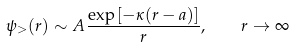Convert formula to latex. <formula><loc_0><loc_0><loc_500><loc_500>\psi _ { > } ( r ) \sim A \frac { \exp \left [ - \kappa ( r - a ) \right ] } { r } , \quad r \to \infty</formula> 